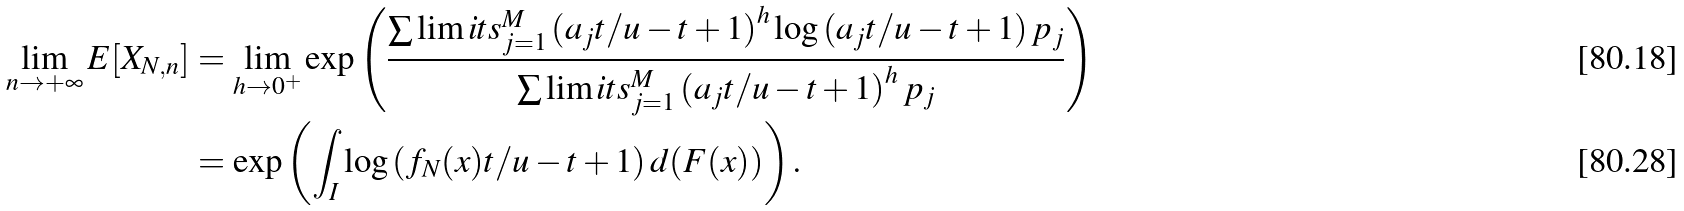Convert formula to latex. <formula><loc_0><loc_0><loc_500><loc_500>\lim _ { n \rightarrow + \infty } E [ X _ { N , n } ] & = \lim _ { h \rightarrow 0 ^ { + } } \exp \left ( \frac { \sum \lim i t s _ { j = 1 } ^ { M } \left ( a _ { j } t / u - t + 1 \right ) ^ { h } \log \left ( a _ { j } t / u - t + 1 \right ) p _ { j } } { \sum \lim i t s _ { j = 1 } ^ { M } \left ( a _ { j } t / u - t + 1 \right ) ^ { h } p _ { j } } \right ) \\ & = \exp \left ( \int _ { I } \log \left ( f _ { N } ( x ) t / u - t + 1 \right ) d ( F ( x ) ) \right ) .</formula> 